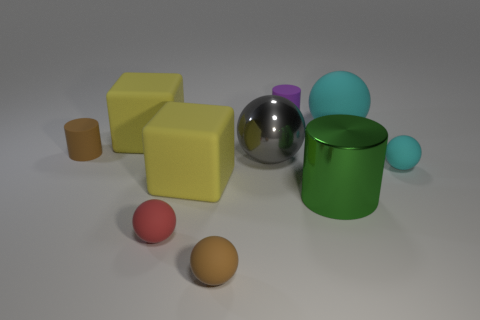Subtract all red balls. How many balls are left? 4 Subtract all brown spheres. How many spheres are left? 4 Subtract all blue balls. Subtract all brown blocks. How many balls are left? 5 Subtract all blocks. How many objects are left? 8 Add 8 big spheres. How many big spheres are left? 10 Add 6 small brown matte objects. How many small brown matte objects exist? 8 Subtract 0 cyan cylinders. How many objects are left? 10 Subtract all large blocks. Subtract all brown cylinders. How many objects are left? 7 